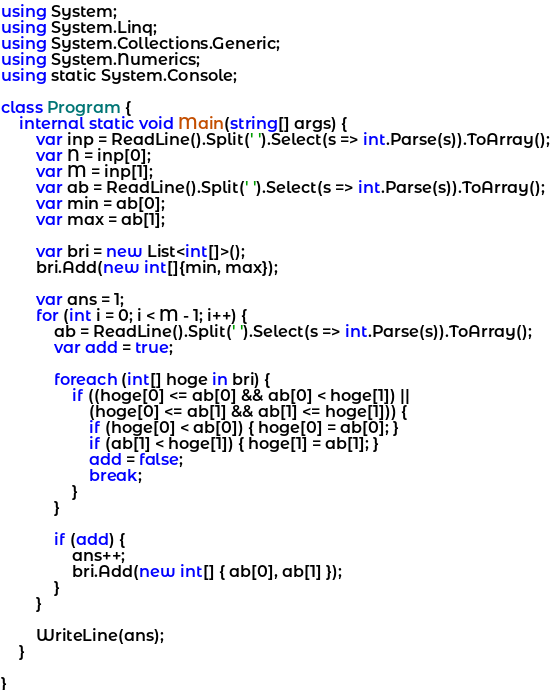Convert code to text. <code><loc_0><loc_0><loc_500><loc_500><_C#_>using System;
using System.Linq;
using System.Collections.Generic;
using System.Numerics;
using static System.Console;

class Program {
    internal static void Main(string[] args) {
        var inp = ReadLine().Split(' ').Select(s => int.Parse(s)).ToArray();
        var N = inp[0];
        var M = inp[1];
        var ab = ReadLine().Split(' ').Select(s => int.Parse(s)).ToArray();
        var min = ab[0];
        var max = ab[1];

        var bri = new List<int[]>();
        bri.Add(new int[]{min, max});

        var ans = 1;
        for (int i = 0; i < M - 1; i++) {
            ab = ReadLine().Split(' ').Select(s => int.Parse(s)).ToArray();
            var add = true;

            foreach (int[] hoge in bri) {
                if ((hoge[0] <= ab[0] && ab[0] < hoge[1]) ||
                    (hoge[0] <= ab[1] && ab[1] <= hoge[1])) {
                    if (hoge[0] < ab[0]) { hoge[0] = ab[0]; }
                    if (ab[1] < hoge[1]) { hoge[1] = ab[1]; }
                    add = false;
                    break;
                }
            }

            if (add) {
                ans++;
                bri.Add(new int[] { ab[0], ab[1] });
            }
        }

        WriteLine(ans);
    }

}</code> 